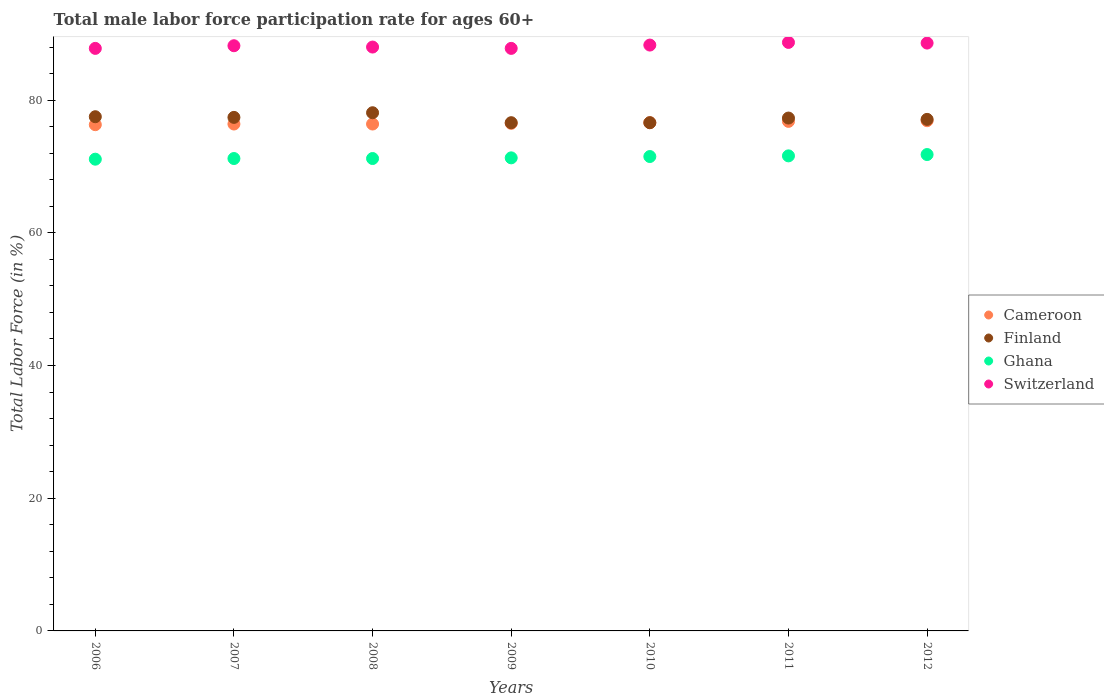Is the number of dotlines equal to the number of legend labels?
Provide a succinct answer. Yes. What is the male labor force participation rate in Switzerland in 2009?
Offer a terse response. 87.8. Across all years, what is the maximum male labor force participation rate in Switzerland?
Your answer should be very brief. 88.7. Across all years, what is the minimum male labor force participation rate in Switzerland?
Your answer should be compact. 87.8. What is the total male labor force participation rate in Switzerland in the graph?
Your answer should be very brief. 617.4. What is the difference between the male labor force participation rate in Ghana in 2008 and that in 2011?
Your response must be concise. -0.4. What is the difference between the male labor force participation rate in Finland in 2011 and the male labor force participation rate in Ghana in 2012?
Offer a terse response. 5.5. What is the average male labor force participation rate in Switzerland per year?
Your answer should be very brief. 88.2. In how many years, is the male labor force participation rate in Cameroon greater than 4 %?
Offer a terse response. 7. What is the ratio of the male labor force participation rate in Finland in 2007 to that in 2011?
Provide a short and direct response. 1. Is the male labor force participation rate in Finland in 2006 less than that in 2011?
Provide a short and direct response. No. Is the difference between the male labor force participation rate in Finland in 2007 and 2008 greater than the difference between the male labor force participation rate in Switzerland in 2007 and 2008?
Offer a very short reply. No. What is the difference between the highest and the second highest male labor force participation rate in Switzerland?
Your answer should be very brief. 0.1. What is the difference between the highest and the lowest male labor force participation rate in Cameroon?
Give a very brief answer. 0.6. Is it the case that in every year, the sum of the male labor force participation rate in Switzerland and male labor force participation rate in Cameroon  is greater than the male labor force participation rate in Ghana?
Keep it short and to the point. Yes. Is the male labor force participation rate in Cameroon strictly greater than the male labor force participation rate in Switzerland over the years?
Provide a succinct answer. No. Is the male labor force participation rate in Finland strictly less than the male labor force participation rate in Switzerland over the years?
Your response must be concise. Yes. How many legend labels are there?
Provide a succinct answer. 4. How are the legend labels stacked?
Provide a short and direct response. Vertical. What is the title of the graph?
Your response must be concise. Total male labor force participation rate for ages 60+. Does "Latin America(all income levels)" appear as one of the legend labels in the graph?
Provide a succinct answer. No. What is the label or title of the Y-axis?
Your response must be concise. Total Labor Force (in %). What is the Total Labor Force (in %) in Cameroon in 2006?
Keep it short and to the point. 76.3. What is the Total Labor Force (in %) in Finland in 2006?
Your response must be concise. 77.5. What is the Total Labor Force (in %) of Ghana in 2006?
Provide a short and direct response. 71.1. What is the Total Labor Force (in %) of Switzerland in 2006?
Offer a very short reply. 87.8. What is the Total Labor Force (in %) in Cameroon in 2007?
Give a very brief answer. 76.4. What is the Total Labor Force (in %) in Finland in 2007?
Give a very brief answer. 77.4. What is the Total Labor Force (in %) in Ghana in 2007?
Make the answer very short. 71.2. What is the Total Labor Force (in %) of Switzerland in 2007?
Offer a very short reply. 88.2. What is the Total Labor Force (in %) of Cameroon in 2008?
Provide a short and direct response. 76.4. What is the Total Labor Force (in %) in Finland in 2008?
Offer a terse response. 78.1. What is the Total Labor Force (in %) of Ghana in 2008?
Your response must be concise. 71.2. What is the Total Labor Force (in %) of Cameroon in 2009?
Your answer should be compact. 76.5. What is the Total Labor Force (in %) in Finland in 2009?
Ensure brevity in your answer.  76.6. What is the Total Labor Force (in %) in Ghana in 2009?
Ensure brevity in your answer.  71.3. What is the Total Labor Force (in %) of Switzerland in 2009?
Provide a succinct answer. 87.8. What is the Total Labor Force (in %) of Cameroon in 2010?
Ensure brevity in your answer.  76.6. What is the Total Labor Force (in %) of Finland in 2010?
Your answer should be very brief. 76.6. What is the Total Labor Force (in %) of Ghana in 2010?
Offer a very short reply. 71.5. What is the Total Labor Force (in %) of Switzerland in 2010?
Ensure brevity in your answer.  88.3. What is the Total Labor Force (in %) in Cameroon in 2011?
Make the answer very short. 76.8. What is the Total Labor Force (in %) of Finland in 2011?
Ensure brevity in your answer.  77.3. What is the Total Labor Force (in %) of Ghana in 2011?
Ensure brevity in your answer.  71.6. What is the Total Labor Force (in %) of Switzerland in 2011?
Make the answer very short. 88.7. What is the Total Labor Force (in %) of Cameroon in 2012?
Make the answer very short. 76.9. What is the Total Labor Force (in %) in Finland in 2012?
Your answer should be compact. 77.1. What is the Total Labor Force (in %) in Ghana in 2012?
Provide a succinct answer. 71.8. What is the Total Labor Force (in %) in Switzerland in 2012?
Keep it short and to the point. 88.6. Across all years, what is the maximum Total Labor Force (in %) in Cameroon?
Offer a very short reply. 76.9. Across all years, what is the maximum Total Labor Force (in %) of Finland?
Give a very brief answer. 78.1. Across all years, what is the maximum Total Labor Force (in %) of Ghana?
Your response must be concise. 71.8. Across all years, what is the maximum Total Labor Force (in %) of Switzerland?
Keep it short and to the point. 88.7. Across all years, what is the minimum Total Labor Force (in %) in Cameroon?
Give a very brief answer. 76.3. Across all years, what is the minimum Total Labor Force (in %) in Finland?
Your answer should be very brief. 76.6. Across all years, what is the minimum Total Labor Force (in %) in Ghana?
Give a very brief answer. 71.1. Across all years, what is the minimum Total Labor Force (in %) in Switzerland?
Your answer should be compact. 87.8. What is the total Total Labor Force (in %) of Cameroon in the graph?
Your response must be concise. 535.9. What is the total Total Labor Force (in %) of Finland in the graph?
Provide a short and direct response. 540.6. What is the total Total Labor Force (in %) in Ghana in the graph?
Your response must be concise. 499.7. What is the total Total Labor Force (in %) of Switzerland in the graph?
Your answer should be compact. 617.4. What is the difference between the Total Labor Force (in %) of Finland in 2006 and that in 2007?
Make the answer very short. 0.1. What is the difference between the Total Labor Force (in %) in Ghana in 2006 and that in 2007?
Offer a very short reply. -0.1. What is the difference between the Total Labor Force (in %) of Switzerland in 2006 and that in 2007?
Your response must be concise. -0.4. What is the difference between the Total Labor Force (in %) of Cameroon in 2006 and that in 2008?
Provide a succinct answer. -0.1. What is the difference between the Total Labor Force (in %) of Finland in 2006 and that in 2008?
Ensure brevity in your answer.  -0.6. What is the difference between the Total Labor Force (in %) of Switzerland in 2006 and that in 2008?
Ensure brevity in your answer.  -0.2. What is the difference between the Total Labor Force (in %) of Cameroon in 2006 and that in 2009?
Make the answer very short. -0.2. What is the difference between the Total Labor Force (in %) in Switzerland in 2006 and that in 2009?
Keep it short and to the point. 0. What is the difference between the Total Labor Force (in %) in Cameroon in 2006 and that in 2010?
Ensure brevity in your answer.  -0.3. What is the difference between the Total Labor Force (in %) in Finland in 2006 and that in 2010?
Provide a succinct answer. 0.9. What is the difference between the Total Labor Force (in %) in Switzerland in 2006 and that in 2010?
Ensure brevity in your answer.  -0.5. What is the difference between the Total Labor Force (in %) of Cameroon in 2006 and that in 2012?
Ensure brevity in your answer.  -0.6. What is the difference between the Total Labor Force (in %) in Switzerland in 2006 and that in 2012?
Your answer should be compact. -0.8. What is the difference between the Total Labor Force (in %) in Cameroon in 2007 and that in 2008?
Provide a succinct answer. 0. What is the difference between the Total Labor Force (in %) of Switzerland in 2007 and that in 2008?
Provide a succinct answer. 0.2. What is the difference between the Total Labor Force (in %) of Ghana in 2007 and that in 2009?
Offer a very short reply. -0.1. What is the difference between the Total Labor Force (in %) in Cameroon in 2007 and that in 2010?
Ensure brevity in your answer.  -0.2. What is the difference between the Total Labor Force (in %) of Finland in 2007 and that in 2010?
Your response must be concise. 0.8. What is the difference between the Total Labor Force (in %) of Switzerland in 2007 and that in 2010?
Your answer should be compact. -0.1. What is the difference between the Total Labor Force (in %) in Finland in 2007 and that in 2011?
Offer a very short reply. 0.1. What is the difference between the Total Labor Force (in %) of Switzerland in 2007 and that in 2011?
Ensure brevity in your answer.  -0.5. What is the difference between the Total Labor Force (in %) in Cameroon in 2007 and that in 2012?
Offer a very short reply. -0.5. What is the difference between the Total Labor Force (in %) in Finland in 2007 and that in 2012?
Your response must be concise. 0.3. What is the difference between the Total Labor Force (in %) in Ghana in 2007 and that in 2012?
Your response must be concise. -0.6. What is the difference between the Total Labor Force (in %) in Switzerland in 2007 and that in 2012?
Give a very brief answer. -0.4. What is the difference between the Total Labor Force (in %) of Cameroon in 2008 and that in 2009?
Your response must be concise. -0.1. What is the difference between the Total Labor Force (in %) of Finland in 2008 and that in 2009?
Your response must be concise. 1.5. What is the difference between the Total Labor Force (in %) of Ghana in 2008 and that in 2009?
Make the answer very short. -0.1. What is the difference between the Total Labor Force (in %) of Cameroon in 2008 and that in 2010?
Make the answer very short. -0.2. What is the difference between the Total Labor Force (in %) in Cameroon in 2008 and that in 2011?
Your response must be concise. -0.4. What is the difference between the Total Labor Force (in %) in Switzerland in 2008 and that in 2011?
Offer a very short reply. -0.7. What is the difference between the Total Labor Force (in %) of Finland in 2008 and that in 2012?
Ensure brevity in your answer.  1. What is the difference between the Total Labor Force (in %) in Ghana in 2008 and that in 2012?
Provide a short and direct response. -0.6. What is the difference between the Total Labor Force (in %) in Cameroon in 2009 and that in 2010?
Offer a terse response. -0.1. What is the difference between the Total Labor Force (in %) in Finland in 2009 and that in 2010?
Your response must be concise. 0. What is the difference between the Total Labor Force (in %) in Ghana in 2009 and that in 2010?
Your response must be concise. -0.2. What is the difference between the Total Labor Force (in %) in Finland in 2009 and that in 2011?
Ensure brevity in your answer.  -0.7. What is the difference between the Total Labor Force (in %) of Ghana in 2009 and that in 2011?
Your answer should be compact. -0.3. What is the difference between the Total Labor Force (in %) in Switzerland in 2009 and that in 2011?
Make the answer very short. -0.9. What is the difference between the Total Labor Force (in %) in Ghana in 2009 and that in 2012?
Ensure brevity in your answer.  -0.5. What is the difference between the Total Labor Force (in %) of Cameroon in 2010 and that in 2011?
Your answer should be compact. -0.2. What is the difference between the Total Labor Force (in %) in Ghana in 2010 and that in 2011?
Give a very brief answer. -0.1. What is the difference between the Total Labor Force (in %) in Switzerland in 2010 and that in 2011?
Keep it short and to the point. -0.4. What is the difference between the Total Labor Force (in %) in Cameroon in 2010 and that in 2012?
Offer a terse response. -0.3. What is the difference between the Total Labor Force (in %) in Ghana in 2010 and that in 2012?
Offer a terse response. -0.3. What is the difference between the Total Labor Force (in %) in Cameroon in 2011 and that in 2012?
Offer a very short reply. -0.1. What is the difference between the Total Labor Force (in %) in Finland in 2011 and that in 2012?
Ensure brevity in your answer.  0.2. What is the difference between the Total Labor Force (in %) of Ghana in 2011 and that in 2012?
Offer a very short reply. -0.2. What is the difference between the Total Labor Force (in %) of Cameroon in 2006 and the Total Labor Force (in %) of Ghana in 2007?
Give a very brief answer. 5.1. What is the difference between the Total Labor Force (in %) in Finland in 2006 and the Total Labor Force (in %) in Ghana in 2007?
Your answer should be compact. 6.3. What is the difference between the Total Labor Force (in %) of Finland in 2006 and the Total Labor Force (in %) of Switzerland in 2007?
Offer a terse response. -10.7. What is the difference between the Total Labor Force (in %) in Ghana in 2006 and the Total Labor Force (in %) in Switzerland in 2007?
Provide a short and direct response. -17.1. What is the difference between the Total Labor Force (in %) of Cameroon in 2006 and the Total Labor Force (in %) of Finland in 2008?
Your answer should be very brief. -1.8. What is the difference between the Total Labor Force (in %) in Cameroon in 2006 and the Total Labor Force (in %) in Ghana in 2008?
Provide a succinct answer. 5.1. What is the difference between the Total Labor Force (in %) of Cameroon in 2006 and the Total Labor Force (in %) of Switzerland in 2008?
Keep it short and to the point. -11.7. What is the difference between the Total Labor Force (in %) of Finland in 2006 and the Total Labor Force (in %) of Ghana in 2008?
Your answer should be compact. 6.3. What is the difference between the Total Labor Force (in %) of Ghana in 2006 and the Total Labor Force (in %) of Switzerland in 2008?
Offer a very short reply. -16.9. What is the difference between the Total Labor Force (in %) of Cameroon in 2006 and the Total Labor Force (in %) of Finland in 2009?
Make the answer very short. -0.3. What is the difference between the Total Labor Force (in %) of Cameroon in 2006 and the Total Labor Force (in %) of Ghana in 2009?
Offer a very short reply. 5. What is the difference between the Total Labor Force (in %) in Cameroon in 2006 and the Total Labor Force (in %) in Switzerland in 2009?
Your answer should be compact. -11.5. What is the difference between the Total Labor Force (in %) in Finland in 2006 and the Total Labor Force (in %) in Ghana in 2009?
Provide a short and direct response. 6.2. What is the difference between the Total Labor Force (in %) of Ghana in 2006 and the Total Labor Force (in %) of Switzerland in 2009?
Provide a succinct answer. -16.7. What is the difference between the Total Labor Force (in %) of Cameroon in 2006 and the Total Labor Force (in %) of Finland in 2010?
Your answer should be very brief. -0.3. What is the difference between the Total Labor Force (in %) of Cameroon in 2006 and the Total Labor Force (in %) of Ghana in 2010?
Your answer should be compact. 4.8. What is the difference between the Total Labor Force (in %) in Finland in 2006 and the Total Labor Force (in %) in Ghana in 2010?
Give a very brief answer. 6. What is the difference between the Total Labor Force (in %) in Ghana in 2006 and the Total Labor Force (in %) in Switzerland in 2010?
Your answer should be very brief. -17.2. What is the difference between the Total Labor Force (in %) in Cameroon in 2006 and the Total Labor Force (in %) in Finland in 2011?
Your answer should be very brief. -1. What is the difference between the Total Labor Force (in %) of Ghana in 2006 and the Total Labor Force (in %) of Switzerland in 2011?
Your answer should be very brief. -17.6. What is the difference between the Total Labor Force (in %) of Cameroon in 2006 and the Total Labor Force (in %) of Finland in 2012?
Offer a very short reply. -0.8. What is the difference between the Total Labor Force (in %) of Cameroon in 2006 and the Total Labor Force (in %) of Switzerland in 2012?
Your response must be concise. -12.3. What is the difference between the Total Labor Force (in %) of Finland in 2006 and the Total Labor Force (in %) of Ghana in 2012?
Your answer should be very brief. 5.7. What is the difference between the Total Labor Force (in %) in Ghana in 2006 and the Total Labor Force (in %) in Switzerland in 2012?
Offer a terse response. -17.5. What is the difference between the Total Labor Force (in %) in Cameroon in 2007 and the Total Labor Force (in %) in Finland in 2008?
Make the answer very short. -1.7. What is the difference between the Total Labor Force (in %) in Cameroon in 2007 and the Total Labor Force (in %) in Ghana in 2008?
Give a very brief answer. 5.2. What is the difference between the Total Labor Force (in %) of Finland in 2007 and the Total Labor Force (in %) of Ghana in 2008?
Your answer should be very brief. 6.2. What is the difference between the Total Labor Force (in %) of Finland in 2007 and the Total Labor Force (in %) of Switzerland in 2008?
Keep it short and to the point. -10.6. What is the difference between the Total Labor Force (in %) in Ghana in 2007 and the Total Labor Force (in %) in Switzerland in 2008?
Offer a terse response. -16.8. What is the difference between the Total Labor Force (in %) in Cameroon in 2007 and the Total Labor Force (in %) in Finland in 2009?
Give a very brief answer. -0.2. What is the difference between the Total Labor Force (in %) in Cameroon in 2007 and the Total Labor Force (in %) in Switzerland in 2009?
Offer a very short reply. -11.4. What is the difference between the Total Labor Force (in %) in Finland in 2007 and the Total Labor Force (in %) in Ghana in 2009?
Ensure brevity in your answer.  6.1. What is the difference between the Total Labor Force (in %) in Finland in 2007 and the Total Labor Force (in %) in Switzerland in 2009?
Your answer should be very brief. -10.4. What is the difference between the Total Labor Force (in %) of Ghana in 2007 and the Total Labor Force (in %) of Switzerland in 2009?
Offer a very short reply. -16.6. What is the difference between the Total Labor Force (in %) in Finland in 2007 and the Total Labor Force (in %) in Switzerland in 2010?
Offer a very short reply. -10.9. What is the difference between the Total Labor Force (in %) in Ghana in 2007 and the Total Labor Force (in %) in Switzerland in 2010?
Provide a short and direct response. -17.1. What is the difference between the Total Labor Force (in %) of Finland in 2007 and the Total Labor Force (in %) of Switzerland in 2011?
Make the answer very short. -11.3. What is the difference between the Total Labor Force (in %) of Ghana in 2007 and the Total Labor Force (in %) of Switzerland in 2011?
Provide a short and direct response. -17.5. What is the difference between the Total Labor Force (in %) in Cameroon in 2007 and the Total Labor Force (in %) in Finland in 2012?
Your answer should be compact. -0.7. What is the difference between the Total Labor Force (in %) in Cameroon in 2007 and the Total Labor Force (in %) in Switzerland in 2012?
Offer a very short reply. -12.2. What is the difference between the Total Labor Force (in %) in Finland in 2007 and the Total Labor Force (in %) in Ghana in 2012?
Your answer should be compact. 5.6. What is the difference between the Total Labor Force (in %) of Ghana in 2007 and the Total Labor Force (in %) of Switzerland in 2012?
Provide a short and direct response. -17.4. What is the difference between the Total Labor Force (in %) in Ghana in 2008 and the Total Labor Force (in %) in Switzerland in 2009?
Provide a succinct answer. -16.6. What is the difference between the Total Labor Force (in %) of Cameroon in 2008 and the Total Labor Force (in %) of Finland in 2010?
Give a very brief answer. -0.2. What is the difference between the Total Labor Force (in %) of Cameroon in 2008 and the Total Labor Force (in %) of Switzerland in 2010?
Provide a short and direct response. -11.9. What is the difference between the Total Labor Force (in %) of Ghana in 2008 and the Total Labor Force (in %) of Switzerland in 2010?
Provide a succinct answer. -17.1. What is the difference between the Total Labor Force (in %) in Cameroon in 2008 and the Total Labor Force (in %) in Finland in 2011?
Offer a terse response. -0.9. What is the difference between the Total Labor Force (in %) in Cameroon in 2008 and the Total Labor Force (in %) in Ghana in 2011?
Your response must be concise. 4.8. What is the difference between the Total Labor Force (in %) of Cameroon in 2008 and the Total Labor Force (in %) of Switzerland in 2011?
Offer a very short reply. -12.3. What is the difference between the Total Labor Force (in %) in Finland in 2008 and the Total Labor Force (in %) in Ghana in 2011?
Your answer should be very brief. 6.5. What is the difference between the Total Labor Force (in %) in Finland in 2008 and the Total Labor Force (in %) in Switzerland in 2011?
Make the answer very short. -10.6. What is the difference between the Total Labor Force (in %) in Ghana in 2008 and the Total Labor Force (in %) in Switzerland in 2011?
Your response must be concise. -17.5. What is the difference between the Total Labor Force (in %) in Cameroon in 2008 and the Total Labor Force (in %) in Finland in 2012?
Make the answer very short. -0.7. What is the difference between the Total Labor Force (in %) of Finland in 2008 and the Total Labor Force (in %) of Ghana in 2012?
Your answer should be compact. 6.3. What is the difference between the Total Labor Force (in %) in Ghana in 2008 and the Total Labor Force (in %) in Switzerland in 2012?
Your answer should be compact. -17.4. What is the difference between the Total Labor Force (in %) in Cameroon in 2009 and the Total Labor Force (in %) in Switzerland in 2010?
Offer a terse response. -11.8. What is the difference between the Total Labor Force (in %) of Cameroon in 2009 and the Total Labor Force (in %) of Finland in 2011?
Offer a terse response. -0.8. What is the difference between the Total Labor Force (in %) of Cameroon in 2009 and the Total Labor Force (in %) of Ghana in 2011?
Your response must be concise. 4.9. What is the difference between the Total Labor Force (in %) of Cameroon in 2009 and the Total Labor Force (in %) of Switzerland in 2011?
Give a very brief answer. -12.2. What is the difference between the Total Labor Force (in %) of Finland in 2009 and the Total Labor Force (in %) of Ghana in 2011?
Keep it short and to the point. 5. What is the difference between the Total Labor Force (in %) of Finland in 2009 and the Total Labor Force (in %) of Switzerland in 2011?
Your answer should be very brief. -12.1. What is the difference between the Total Labor Force (in %) in Ghana in 2009 and the Total Labor Force (in %) in Switzerland in 2011?
Ensure brevity in your answer.  -17.4. What is the difference between the Total Labor Force (in %) of Cameroon in 2009 and the Total Labor Force (in %) of Ghana in 2012?
Your answer should be very brief. 4.7. What is the difference between the Total Labor Force (in %) in Finland in 2009 and the Total Labor Force (in %) in Ghana in 2012?
Provide a succinct answer. 4.8. What is the difference between the Total Labor Force (in %) of Finland in 2009 and the Total Labor Force (in %) of Switzerland in 2012?
Provide a succinct answer. -12. What is the difference between the Total Labor Force (in %) of Ghana in 2009 and the Total Labor Force (in %) of Switzerland in 2012?
Your answer should be very brief. -17.3. What is the difference between the Total Labor Force (in %) in Cameroon in 2010 and the Total Labor Force (in %) in Finland in 2011?
Offer a terse response. -0.7. What is the difference between the Total Labor Force (in %) of Cameroon in 2010 and the Total Labor Force (in %) of Ghana in 2011?
Ensure brevity in your answer.  5. What is the difference between the Total Labor Force (in %) in Finland in 2010 and the Total Labor Force (in %) in Switzerland in 2011?
Give a very brief answer. -12.1. What is the difference between the Total Labor Force (in %) of Ghana in 2010 and the Total Labor Force (in %) of Switzerland in 2011?
Keep it short and to the point. -17.2. What is the difference between the Total Labor Force (in %) of Cameroon in 2010 and the Total Labor Force (in %) of Switzerland in 2012?
Ensure brevity in your answer.  -12. What is the difference between the Total Labor Force (in %) in Finland in 2010 and the Total Labor Force (in %) in Ghana in 2012?
Your answer should be compact. 4.8. What is the difference between the Total Labor Force (in %) in Finland in 2010 and the Total Labor Force (in %) in Switzerland in 2012?
Your answer should be very brief. -12. What is the difference between the Total Labor Force (in %) of Ghana in 2010 and the Total Labor Force (in %) of Switzerland in 2012?
Your answer should be compact. -17.1. What is the difference between the Total Labor Force (in %) of Cameroon in 2011 and the Total Labor Force (in %) of Ghana in 2012?
Give a very brief answer. 5. What is the difference between the Total Labor Force (in %) of Cameroon in 2011 and the Total Labor Force (in %) of Switzerland in 2012?
Your response must be concise. -11.8. What is the difference between the Total Labor Force (in %) in Finland in 2011 and the Total Labor Force (in %) in Switzerland in 2012?
Your answer should be very brief. -11.3. What is the difference between the Total Labor Force (in %) of Ghana in 2011 and the Total Labor Force (in %) of Switzerland in 2012?
Your response must be concise. -17. What is the average Total Labor Force (in %) in Cameroon per year?
Provide a short and direct response. 76.56. What is the average Total Labor Force (in %) in Finland per year?
Keep it short and to the point. 77.23. What is the average Total Labor Force (in %) of Ghana per year?
Your response must be concise. 71.39. What is the average Total Labor Force (in %) of Switzerland per year?
Your answer should be compact. 88.2. In the year 2006, what is the difference between the Total Labor Force (in %) of Cameroon and Total Labor Force (in %) of Ghana?
Ensure brevity in your answer.  5.2. In the year 2006, what is the difference between the Total Labor Force (in %) of Cameroon and Total Labor Force (in %) of Switzerland?
Your response must be concise. -11.5. In the year 2006, what is the difference between the Total Labor Force (in %) in Finland and Total Labor Force (in %) in Ghana?
Your response must be concise. 6.4. In the year 2006, what is the difference between the Total Labor Force (in %) of Finland and Total Labor Force (in %) of Switzerland?
Keep it short and to the point. -10.3. In the year 2006, what is the difference between the Total Labor Force (in %) in Ghana and Total Labor Force (in %) in Switzerland?
Ensure brevity in your answer.  -16.7. In the year 2007, what is the difference between the Total Labor Force (in %) of Cameroon and Total Labor Force (in %) of Finland?
Your answer should be very brief. -1. In the year 2008, what is the difference between the Total Labor Force (in %) in Cameroon and Total Labor Force (in %) in Finland?
Your answer should be very brief. -1.7. In the year 2008, what is the difference between the Total Labor Force (in %) in Cameroon and Total Labor Force (in %) in Switzerland?
Make the answer very short. -11.6. In the year 2008, what is the difference between the Total Labor Force (in %) of Ghana and Total Labor Force (in %) of Switzerland?
Provide a short and direct response. -16.8. In the year 2009, what is the difference between the Total Labor Force (in %) in Cameroon and Total Labor Force (in %) in Finland?
Make the answer very short. -0.1. In the year 2009, what is the difference between the Total Labor Force (in %) in Cameroon and Total Labor Force (in %) in Ghana?
Ensure brevity in your answer.  5.2. In the year 2009, what is the difference between the Total Labor Force (in %) in Cameroon and Total Labor Force (in %) in Switzerland?
Make the answer very short. -11.3. In the year 2009, what is the difference between the Total Labor Force (in %) of Finland and Total Labor Force (in %) of Ghana?
Your answer should be compact. 5.3. In the year 2009, what is the difference between the Total Labor Force (in %) of Finland and Total Labor Force (in %) of Switzerland?
Give a very brief answer. -11.2. In the year 2009, what is the difference between the Total Labor Force (in %) of Ghana and Total Labor Force (in %) of Switzerland?
Offer a terse response. -16.5. In the year 2010, what is the difference between the Total Labor Force (in %) of Cameroon and Total Labor Force (in %) of Ghana?
Keep it short and to the point. 5.1. In the year 2010, what is the difference between the Total Labor Force (in %) in Cameroon and Total Labor Force (in %) in Switzerland?
Make the answer very short. -11.7. In the year 2010, what is the difference between the Total Labor Force (in %) in Finland and Total Labor Force (in %) in Ghana?
Give a very brief answer. 5.1. In the year 2010, what is the difference between the Total Labor Force (in %) in Finland and Total Labor Force (in %) in Switzerland?
Provide a succinct answer. -11.7. In the year 2010, what is the difference between the Total Labor Force (in %) of Ghana and Total Labor Force (in %) of Switzerland?
Ensure brevity in your answer.  -16.8. In the year 2011, what is the difference between the Total Labor Force (in %) of Cameroon and Total Labor Force (in %) of Ghana?
Provide a short and direct response. 5.2. In the year 2011, what is the difference between the Total Labor Force (in %) in Cameroon and Total Labor Force (in %) in Switzerland?
Provide a succinct answer. -11.9. In the year 2011, what is the difference between the Total Labor Force (in %) in Ghana and Total Labor Force (in %) in Switzerland?
Provide a short and direct response. -17.1. In the year 2012, what is the difference between the Total Labor Force (in %) in Finland and Total Labor Force (in %) in Ghana?
Your answer should be very brief. 5.3. In the year 2012, what is the difference between the Total Labor Force (in %) in Ghana and Total Labor Force (in %) in Switzerland?
Your response must be concise. -16.8. What is the ratio of the Total Labor Force (in %) in Cameroon in 2006 to that in 2008?
Your answer should be very brief. 1. What is the ratio of the Total Labor Force (in %) of Finland in 2006 to that in 2008?
Your answer should be compact. 0.99. What is the ratio of the Total Labor Force (in %) of Ghana in 2006 to that in 2008?
Your response must be concise. 1. What is the ratio of the Total Labor Force (in %) in Switzerland in 2006 to that in 2008?
Offer a very short reply. 1. What is the ratio of the Total Labor Force (in %) in Finland in 2006 to that in 2009?
Offer a very short reply. 1.01. What is the ratio of the Total Labor Force (in %) of Switzerland in 2006 to that in 2009?
Make the answer very short. 1. What is the ratio of the Total Labor Force (in %) of Finland in 2006 to that in 2010?
Make the answer very short. 1.01. What is the ratio of the Total Labor Force (in %) of Ghana in 2006 to that in 2010?
Your answer should be very brief. 0.99. What is the ratio of the Total Labor Force (in %) in Switzerland in 2006 to that in 2010?
Make the answer very short. 0.99. What is the ratio of the Total Labor Force (in %) in Finland in 2006 to that in 2011?
Provide a succinct answer. 1. What is the ratio of the Total Labor Force (in %) in Ghana in 2006 to that in 2011?
Provide a short and direct response. 0.99. What is the ratio of the Total Labor Force (in %) of Switzerland in 2006 to that in 2011?
Your answer should be compact. 0.99. What is the ratio of the Total Labor Force (in %) of Finland in 2006 to that in 2012?
Offer a very short reply. 1.01. What is the ratio of the Total Labor Force (in %) in Ghana in 2006 to that in 2012?
Make the answer very short. 0.99. What is the ratio of the Total Labor Force (in %) of Switzerland in 2006 to that in 2012?
Offer a terse response. 0.99. What is the ratio of the Total Labor Force (in %) of Ghana in 2007 to that in 2008?
Make the answer very short. 1. What is the ratio of the Total Labor Force (in %) in Switzerland in 2007 to that in 2008?
Keep it short and to the point. 1. What is the ratio of the Total Labor Force (in %) of Finland in 2007 to that in 2009?
Provide a succinct answer. 1.01. What is the ratio of the Total Labor Force (in %) of Finland in 2007 to that in 2010?
Your answer should be very brief. 1.01. What is the ratio of the Total Labor Force (in %) in Ghana in 2007 to that in 2010?
Your answer should be compact. 1. What is the ratio of the Total Labor Force (in %) of Cameroon in 2007 to that in 2011?
Your answer should be compact. 0.99. What is the ratio of the Total Labor Force (in %) of Finland in 2007 to that in 2011?
Provide a short and direct response. 1. What is the ratio of the Total Labor Force (in %) in Ghana in 2007 to that in 2011?
Your answer should be very brief. 0.99. What is the ratio of the Total Labor Force (in %) in Switzerland in 2007 to that in 2011?
Make the answer very short. 0.99. What is the ratio of the Total Labor Force (in %) of Finland in 2007 to that in 2012?
Keep it short and to the point. 1. What is the ratio of the Total Labor Force (in %) of Ghana in 2007 to that in 2012?
Your response must be concise. 0.99. What is the ratio of the Total Labor Force (in %) in Switzerland in 2007 to that in 2012?
Ensure brevity in your answer.  1. What is the ratio of the Total Labor Force (in %) in Cameroon in 2008 to that in 2009?
Provide a succinct answer. 1. What is the ratio of the Total Labor Force (in %) in Finland in 2008 to that in 2009?
Keep it short and to the point. 1.02. What is the ratio of the Total Labor Force (in %) of Ghana in 2008 to that in 2009?
Make the answer very short. 1. What is the ratio of the Total Labor Force (in %) in Finland in 2008 to that in 2010?
Make the answer very short. 1.02. What is the ratio of the Total Labor Force (in %) in Ghana in 2008 to that in 2010?
Provide a short and direct response. 1. What is the ratio of the Total Labor Force (in %) of Cameroon in 2008 to that in 2011?
Your answer should be very brief. 0.99. What is the ratio of the Total Labor Force (in %) of Finland in 2008 to that in 2011?
Provide a short and direct response. 1.01. What is the ratio of the Total Labor Force (in %) in Cameroon in 2008 to that in 2012?
Give a very brief answer. 0.99. What is the ratio of the Total Labor Force (in %) of Finland in 2008 to that in 2012?
Your answer should be compact. 1.01. What is the ratio of the Total Labor Force (in %) of Switzerland in 2009 to that in 2010?
Your answer should be very brief. 0.99. What is the ratio of the Total Labor Force (in %) of Cameroon in 2009 to that in 2011?
Keep it short and to the point. 1. What is the ratio of the Total Labor Force (in %) of Finland in 2009 to that in 2011?
Keep it short and to the point. 0.99. What is the ratio of the Total Labor Force (in %) in Switzerland in 2009 to that in 2011?
Give a very brief answer. 0.99. What is the ratio of the Total Labor Force (in %) in Cameroon in 2009 to that in 2012?
Offer a terse response. 0.99. What is the ratio of the Total Labor Force (in %) of Finland in 2009 to that in 2012?
Offer a terse response. 0.99. What is the ratio of the Total Labor Force (in %) of Cameroon in 2010 to that in 2011?
Keep it short and to the point. 1. What is the ratio of the Total Labor Force (in %) in Finland in 2010 to that in 2011?
Keep it short and to the point. 0.99. What is the ratio of the Total Labor Force (in %) in Ghana in 2010 to that in 2011?
Provide a succinct answer. 1. What is the ratio of the Total Labor Force (in %) in Switzerland in 2010 to that in 2011?
Ensure brevity in your answer.  1. What is the ratio of the Total Labor Force (in %) of Cameroon in 2011 to that in 2012?
Offer a terse response. 1. What is the ratio of the Total Labor Force (in %) of Ghana in 2011 to that in 2012?
Ensure brevity in your answer.  1. What is the ratio of the Total Labor Force (in %) of Switzerland in 2011 to that in 2012?
Provide a short and direct response. 1. What is the difference between the highest and the second highest Total Labor Force (in %) of Ghana?
Keep it short and to the point. 0.2. What is the difference between the highest and the second highest Total Labor Force (in %) in Switzerland?
Offer a very short reply. 0.1. What is the difference between the highest and the lowest Total Labor Force (in %) of Cameroon?
Offer a very short reply. 0.6. What is the difference between the highest and the lowest Total Labor Force (in %) in Finland?
Provide a succinct answer. 1.5. What is the difference between the highest and the lowest Total Labor Force (in %) in Switzerland?
Your answer should be compact. 0.9. 